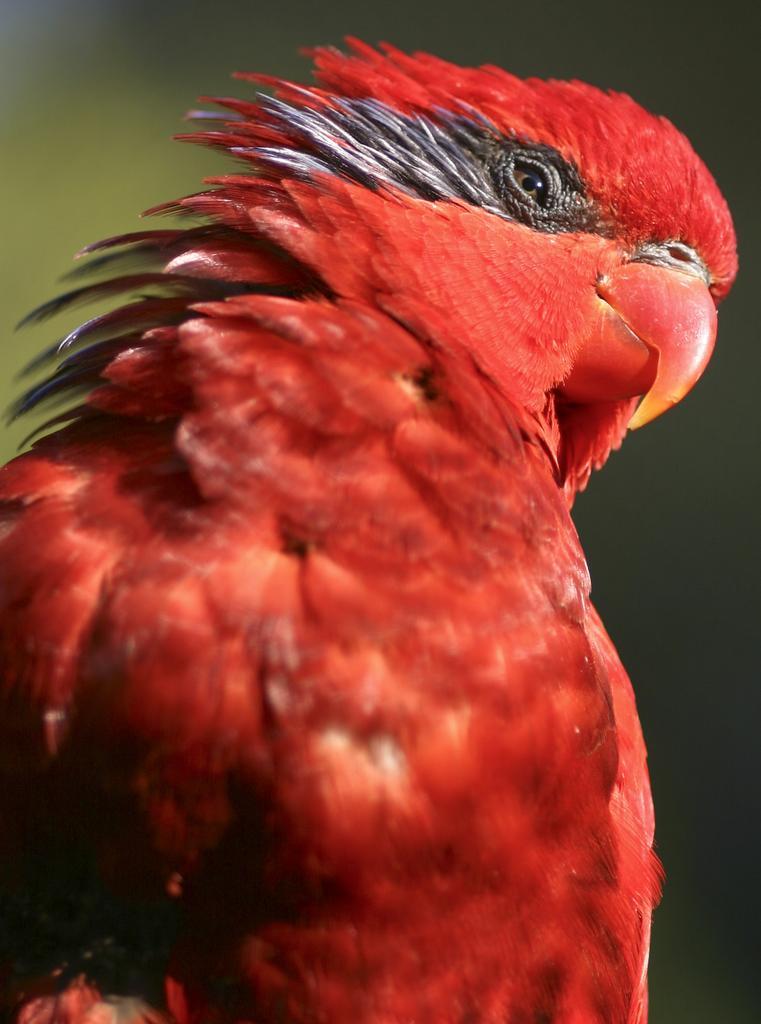Could you give a brief overview of what you see in this image? In the image there is a bird, it is in red colour and the background of the bird is blue. 